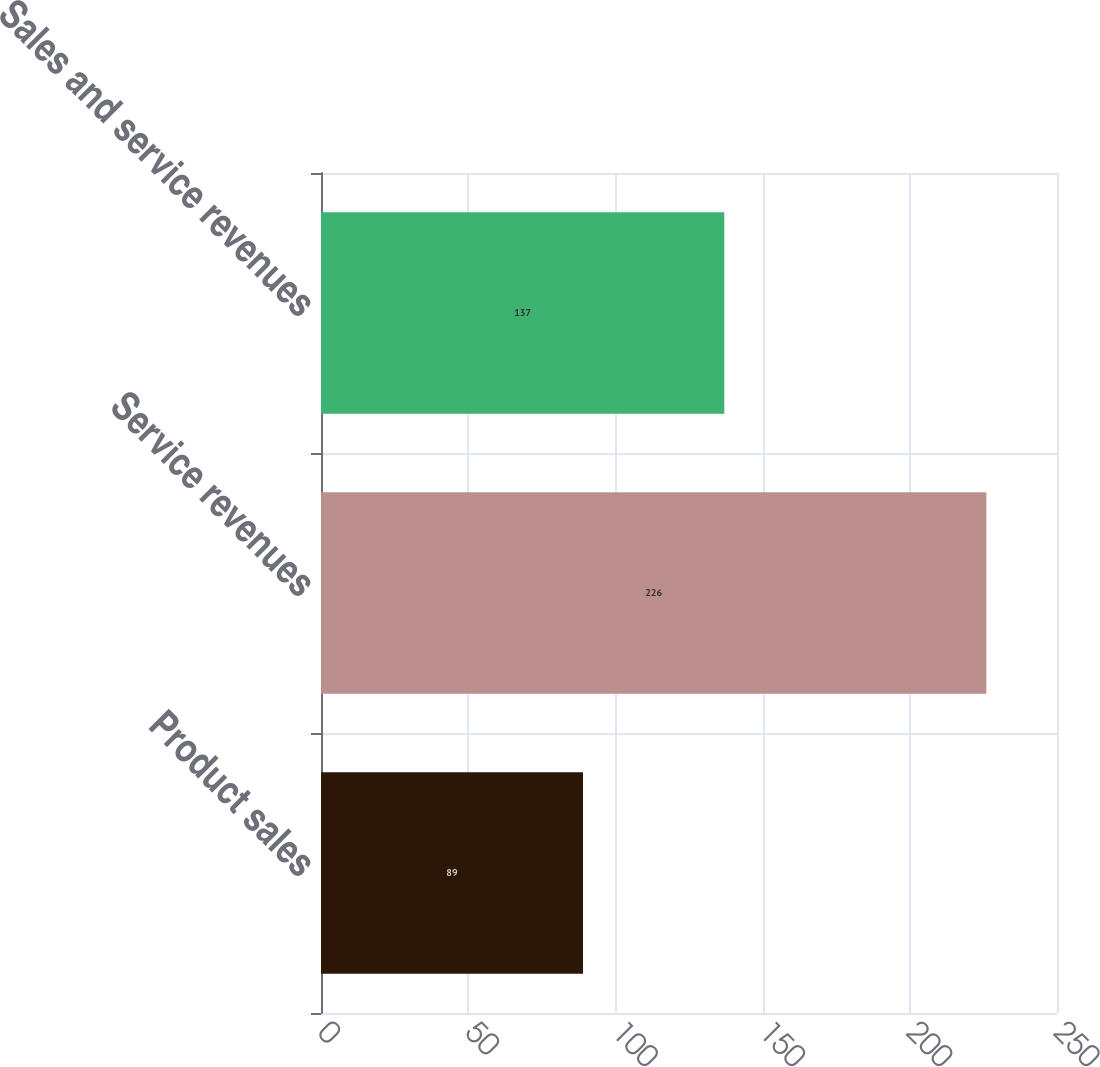Convert chart to OTSL. <chart><loc_0><loc_0><loc_500><loc_500><bar_chart><fcel>Product sales<fcel>Service revenues<fcel>Sales and service revenues<nl><fcel>89<fcel>226<fcel>137<nl></chart> 